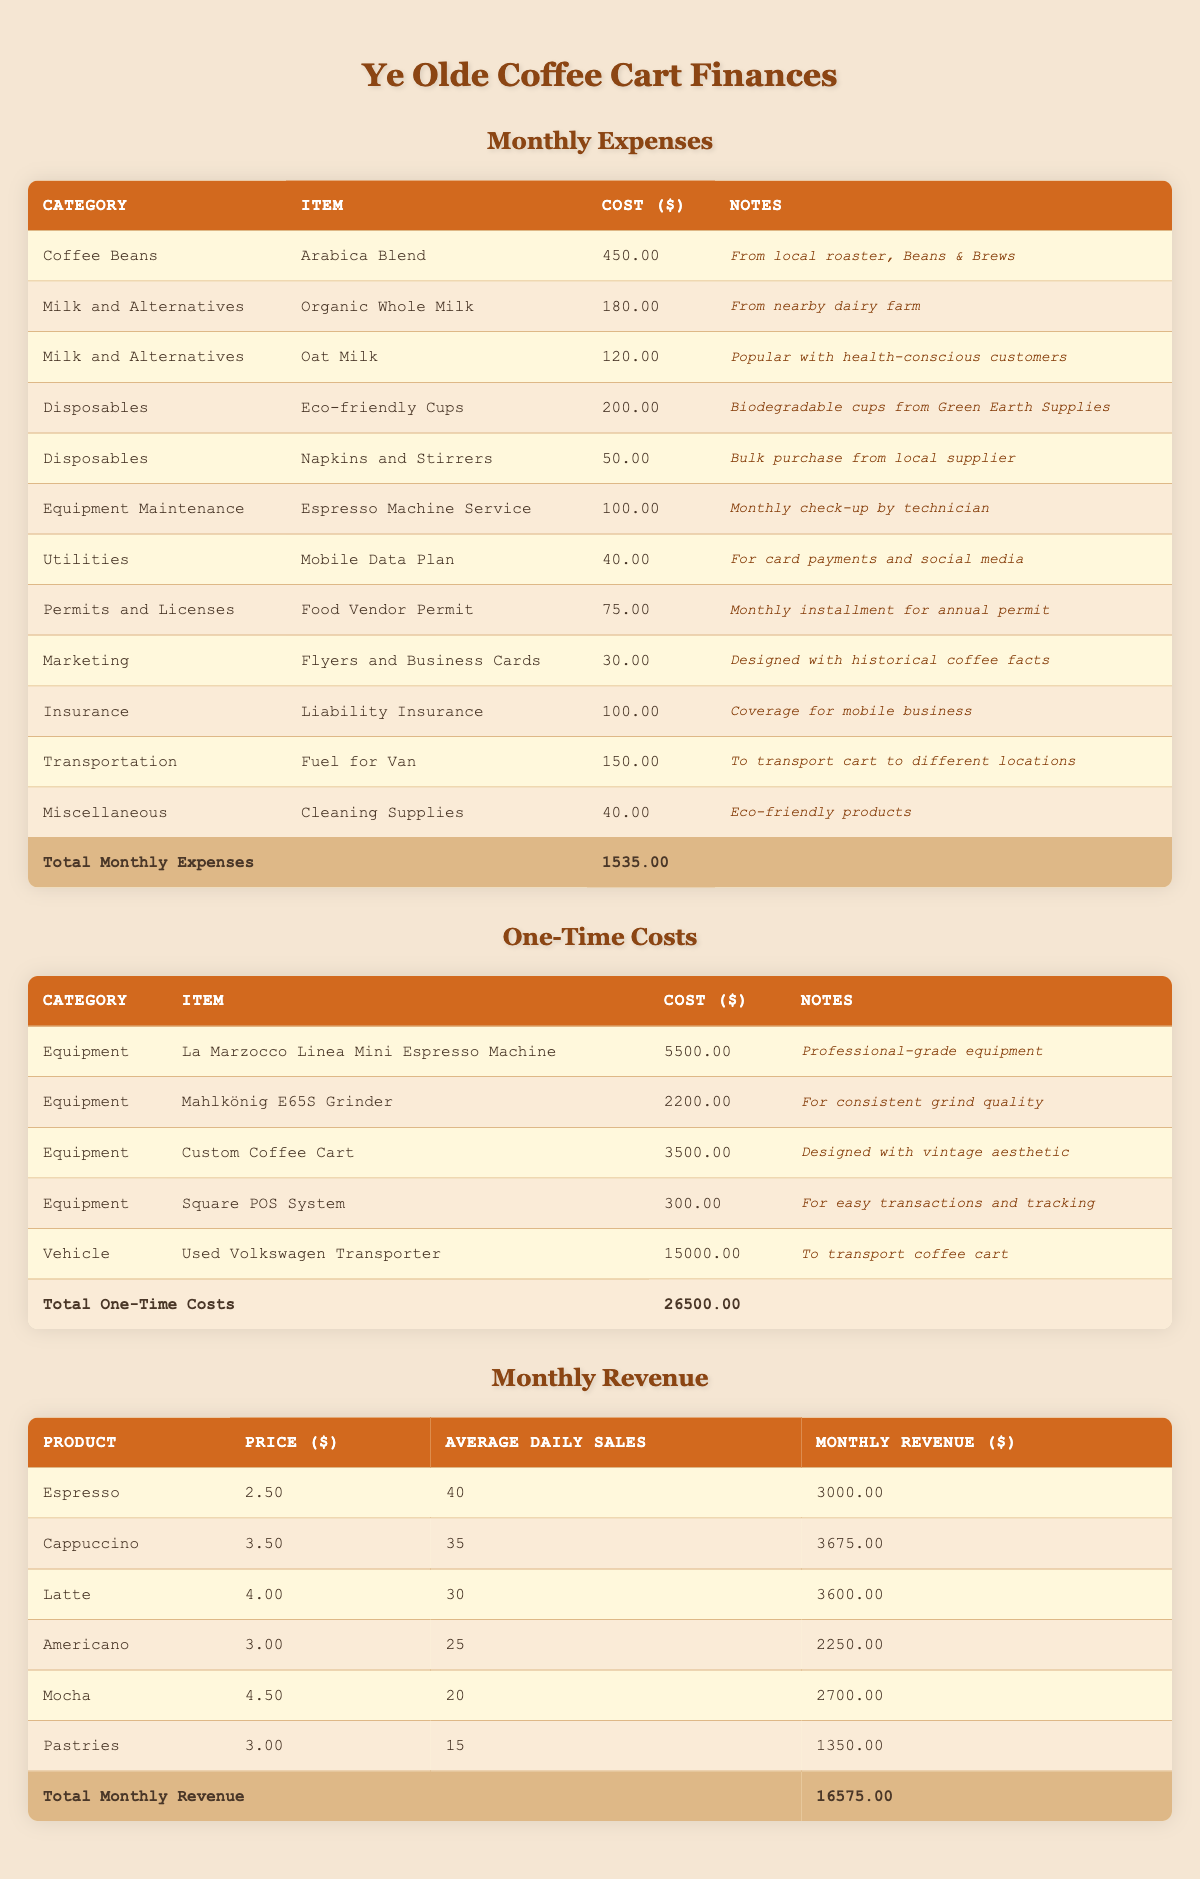What is the total cost for the Milk and Alternatives category? The Milk and Alternatives category includes two items: Organic Whole Milk costing 180.00 and Oat Milk costing 120.00. Summing these costs gives us 180.00 + 120.00 = 300.00.
Answer: 300.00 How much is spent on Disposables each month? The Disposables category has two items: Eco-friendly Cups costing 200.00 and Napkins and Stirrers costing 50.00. Adding these amounts together results in a monthly disposable cost of 200.00 + 50.00 = 250.00.
Answer: 250.00 Is the total monthly revenue greater than the total monthly expenses? The total monthly revenue is listed as 16575.00, and the total monthly expenses are 1535.00. Since 16575.00 is greater than 1535.00, the statement is true.
Answer: Yes What is the total one-time cost for all Equipment items? The Equipment items include the following costs: La Marzocco Linea Mini Espresso Machine at 5500.00, Mahlkönig E65S Grinder at 2200.00, Custom Coffee Cart at 3500.00, and Square POS System at 300.00. Adding these values results in a sum of 5500.00 + 2200.00 + 3500.00 + 300.00 = 11500.00.
Answer: 11500.00 What is the average monthly revenue across all products? The monthly revenues for the products are: Espresso at 3000.00, Cappuccino at 3675.00, Latte at 3600.00, Americano at 2250.00, Mocha at 2700.00, and Pastries at 1350.00. To find the average, sum them up: 3000 + 3675 + 3600 + 2250 + 2700 + 1350 = 16575. Breaking this down into six products, we calculate the average as 16575.00 / 6 = 2762.50.
Answer: 2762.50 Are there any monthly expenses related to marketing? Yes, there is a monthly expense under the Marketing category for Flyers and Business Cards, which costs 30.00. The presence of this item confirms that there are indeed marketing expenses.
Answer: Yes 